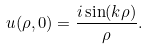<formula> <loc_0><loc_0><loc_500><loc_500>u ( \rho , 0 ) = \frac { i \sin ( k \rho ) } { \rho } .</formula> 